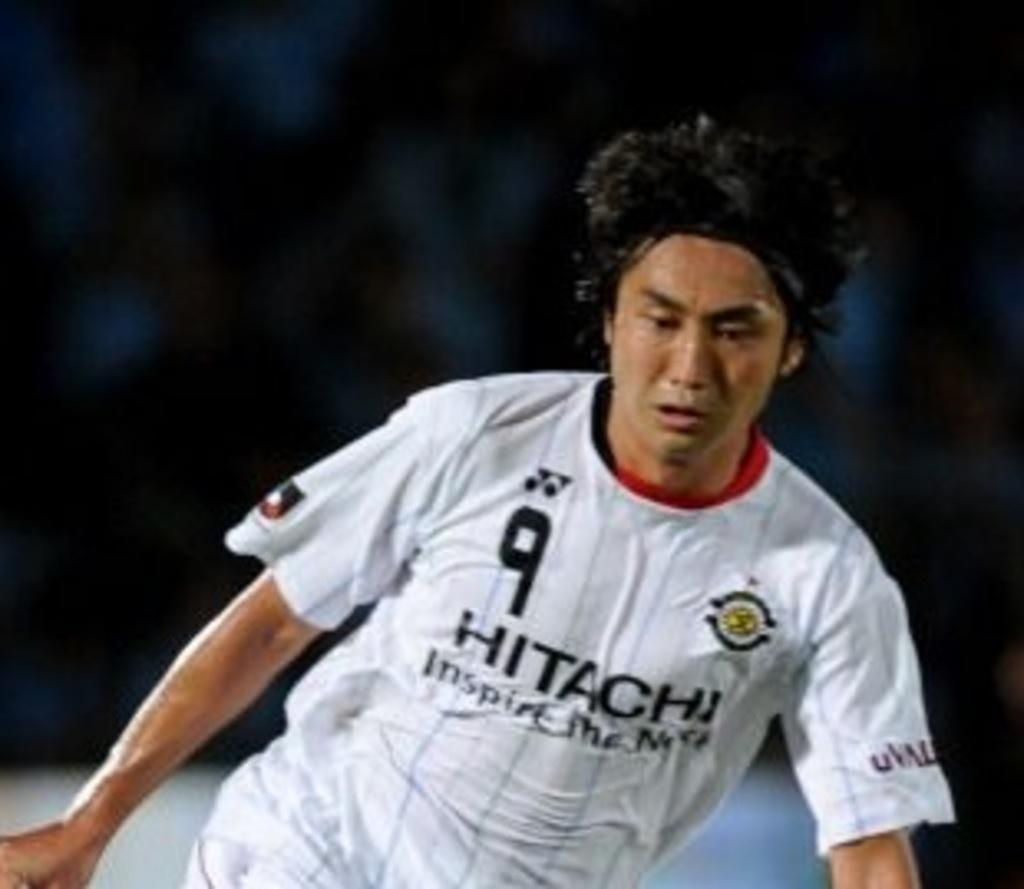<image>
Create a compact narrative representing the image presented. a boy wearing a white jersey that says '9 hitachi' on it 